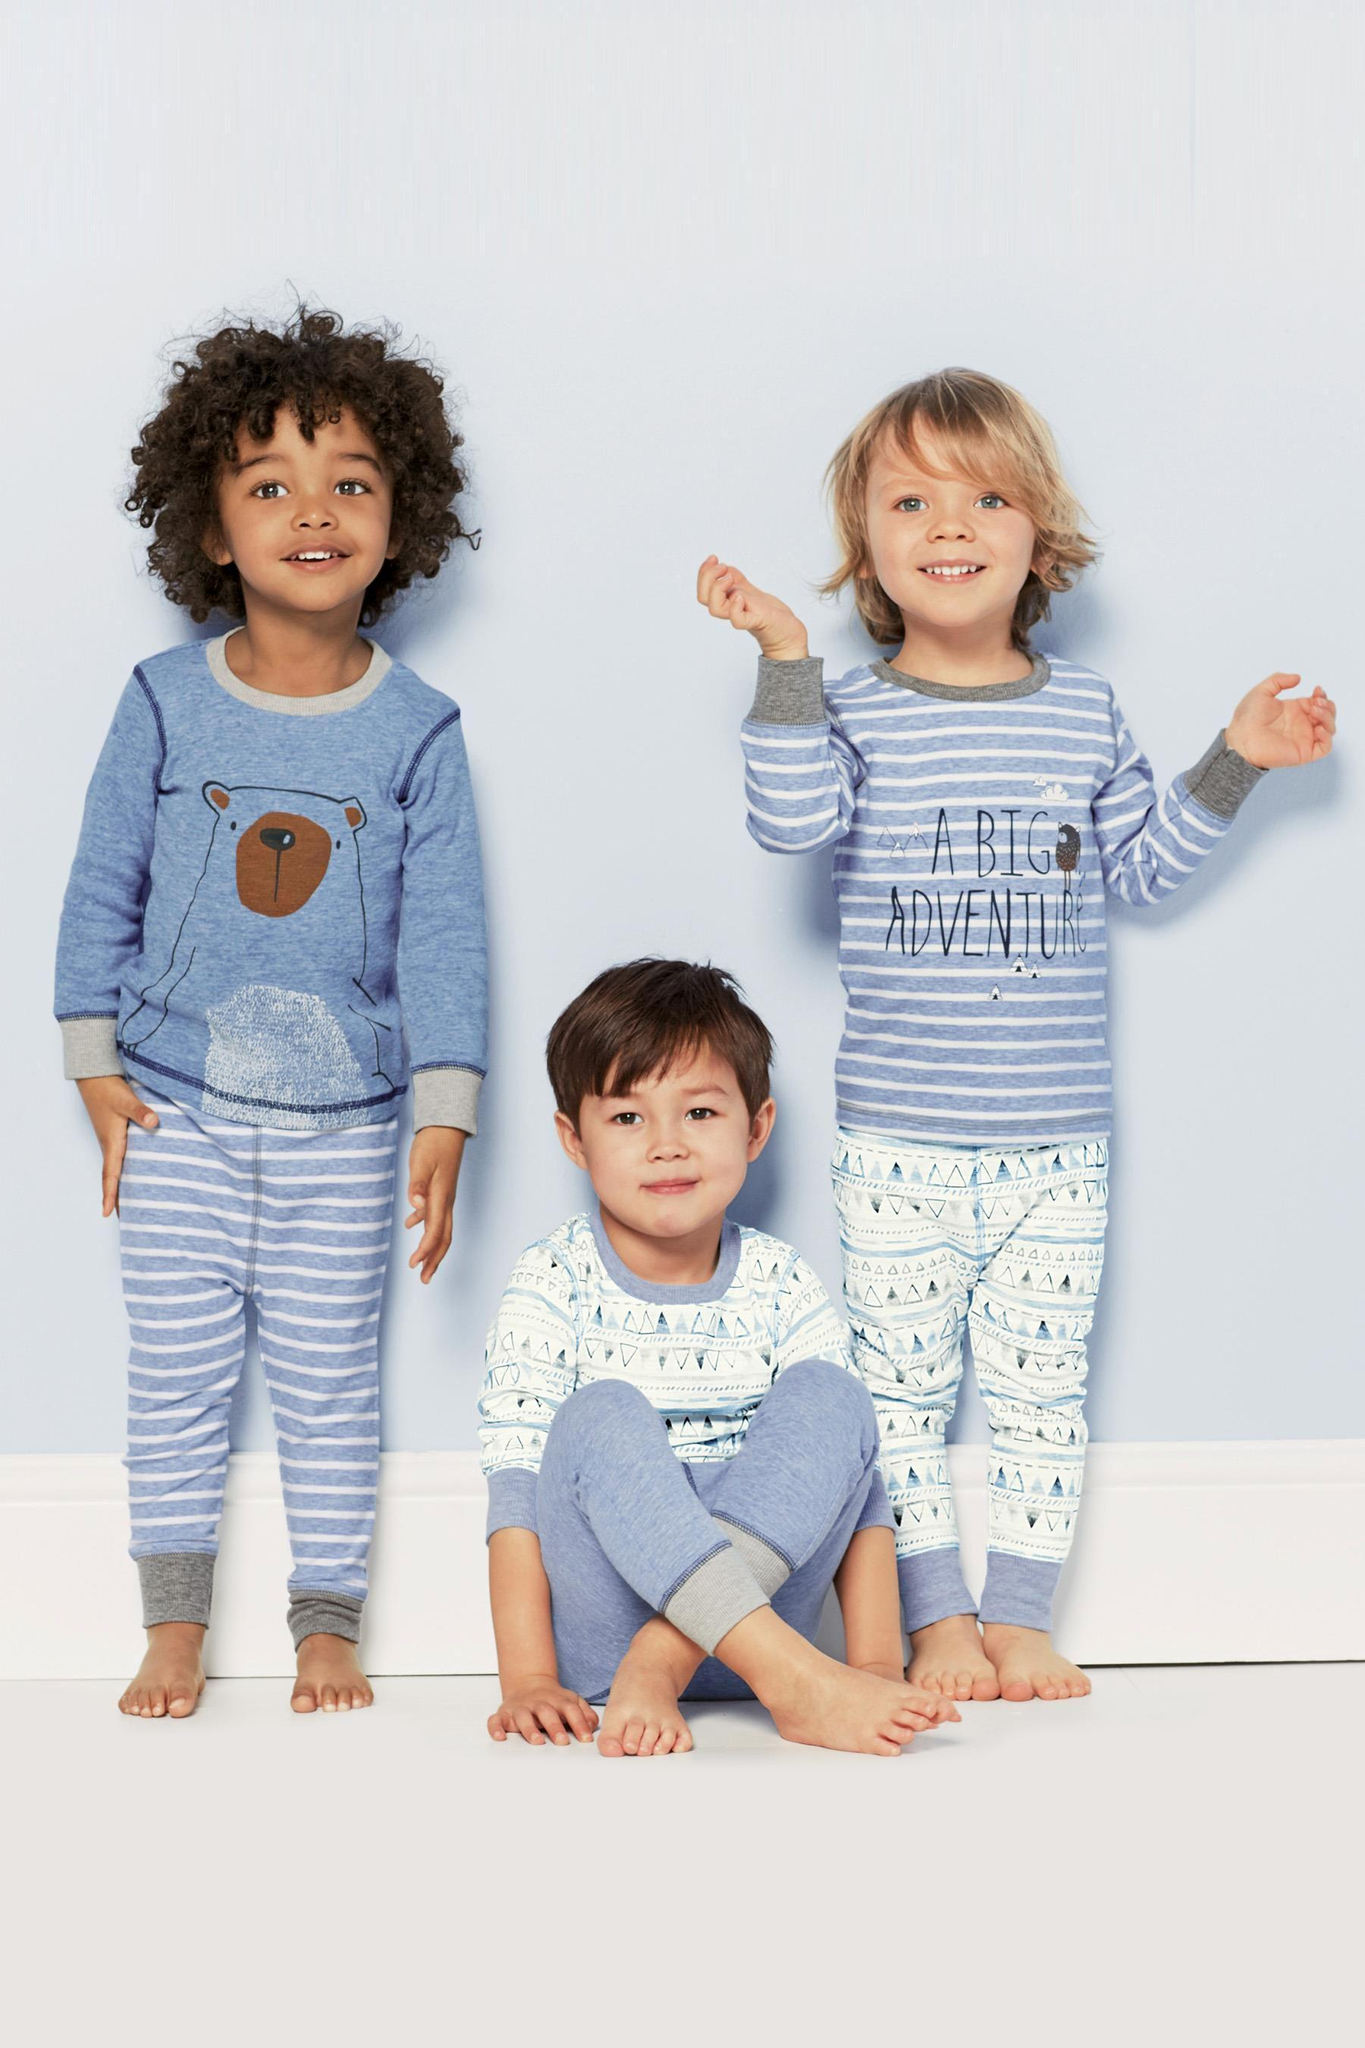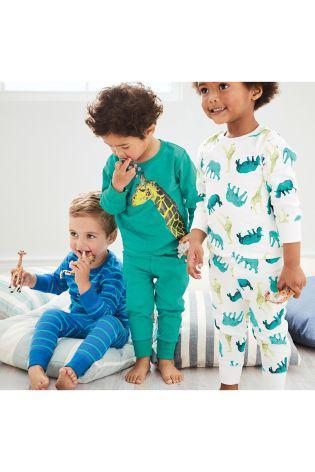The first image is the image on the left, the second image is the image on the right. Examine the images to the left and right. Is the description "There is a boy wearing pajamas in the center of each image." accurate? Answer yes or no. Yes. The first image is the image on the left, the second image is the image on the right. Evaluate the accuracy of this statement regarding the images: "the left image has the middle child sitting criss cross". Is it true? Answer yes or no. Yes. 